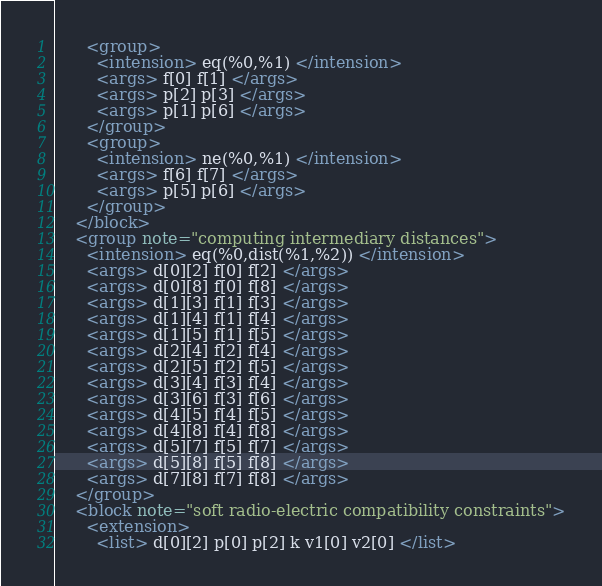<code> <loc_0><loc_0><loc_500><loc_500><_XML_>      <group>
        <intension> eq(%0,%1) </intension>
        <args> f[0] f[1] </args>
        <args> p[2] p[3] </args>
        <args> p[1] p[6] </args>
      </group>
      <group>
        <intension> ne(%0,%1) </intension>
        <args> f[6] f[7] </args>
        <args> p[5] p[6] </args>
      </group>
    </block>
    <group note="computing intermediary distances">
      <intension> eq(%0,dist(%1,%2)) </intension>
      <args> d[0][2] f[0] f[2] </args>
      <args> d[0][8] f[0] f[8] </args>
      <args> d[1][3] f[1] f[3] </args>
      <args> d[1][4] f[1] f[4] </args>
      <args> d[1][5] f[1] f[5] </args>
      <args> d[2][4] f[2] f[4] </args>
      <args> d[2][5] f[2] f[5] </args>
      <args> d[3][4] f[3] f[4] </args>
      <args> d[3][6] f[3] f[6] </args>
      <args> d[4][5] f[4] f[5] </args>
      <args> d[4][8] f[4] f[8] </args>
      <args> d[5][7] f[5] f[7] </args>
      <args> d[5][8] f[5] f[8] </args>
      <args> d[7][8] f[7] f[8] </args>
    </group>
    <block note="soft radio-electric compatibility constraints">
      <extension>
        <list> d[0][2] p[0] p[2] k v1[0] v2[0] </list></code> 